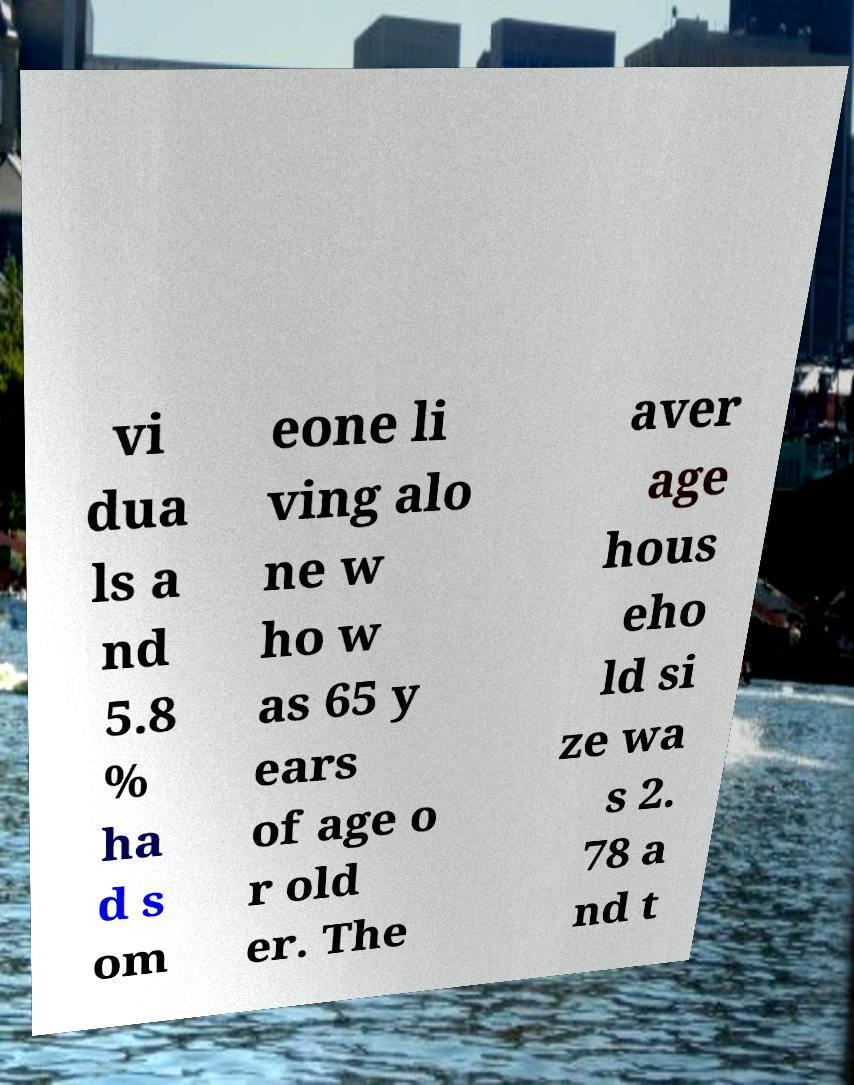Please read and relay the text visible in this image. What does it say? vi dua ls a nd 5.8 % ha d s om eone li ving alo ne w ho w as 65 y ears of age o r old er. The aver age hous eho ld si ze wa s 2. 78 a nd t 